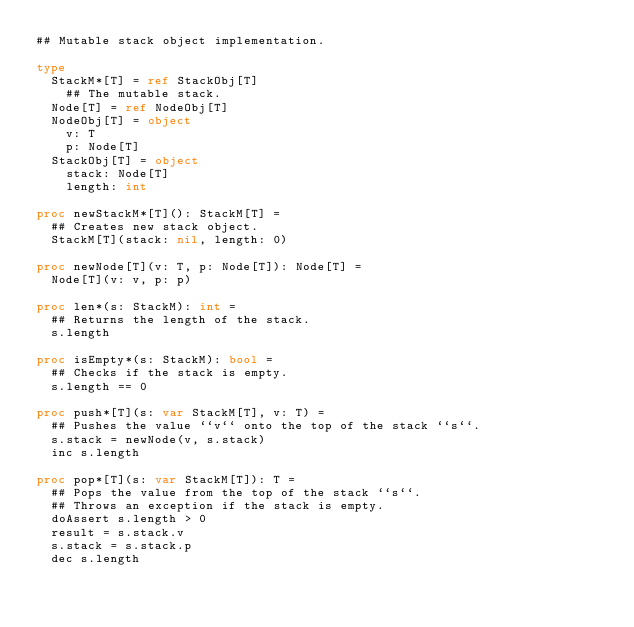Convert code to text. <code><loc_0><loc_0><loc_500><loc_500><_Nim_>## Mutable stack object implementation.

type
  StackM*[T] = ref StackObj[T]
    ## The mutable stack.
  Node[T] = ref NodeObj[T]
  NodeObj[T] = object
    v: T
    p: Node[T]
  StackObj[T] = object
    stack: Node[T]
    length: int

proc newStackM*[T](): StackM[T] =
  ## Creates new stack object.
  StackM[T](stack: nil, length: 0)

proc newNode[T](v: T, p: Node[T]): Node[T] =
  Node[T](v: v, p: p)

proc len*(s: StackM): int =
  ## Returns the length of the stack.
  s.length

proc isEmpty*(s: StackM): bool =
  ## Checks if the stack is empty.
  s.length == 0

proc push*[T](s: var StackM[T], v: T) =
  ## Pushes the value ``v`` onto the top of the stack ``s``.
  s.stack = newNode(v, s.stack)
  inc s.length

proc pop*[T](s: var StackM[T]): T =
  ## Pops the value from the top of the stack ``s``.
  ## Throws an exception if the stack is empty.
  doAssert s.length > 0
  result = s.stack.v
  s.stack = s.stack.p
  dec s.length
</code> 